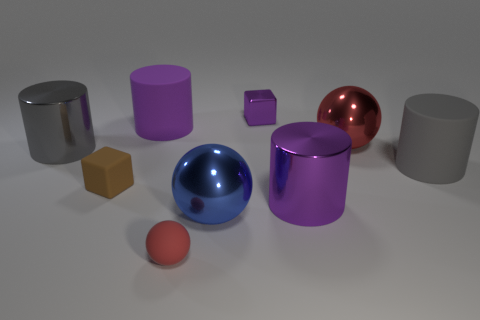Add 1 gray rubber cylinders. How many objects exist? 10 Subtract all blocks. How many objects are left? 7 Subtract all large metallic cylinders. Subtract all purple rubber things. How many objects are left? 6 Add 6 big balls. How many big balls are left? 8 Add 6 small metal cubes. How many small metal cubes exist? 7 Subtract 0 yellow cylinders. How many objects are left? 9 